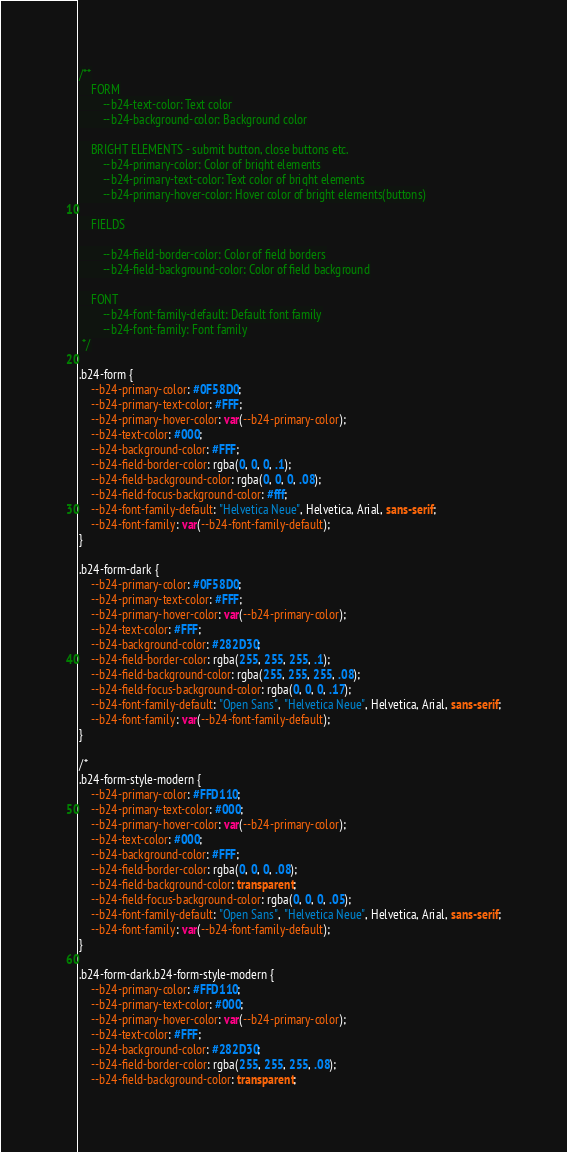<code> <loc_0><loc_0><loc_500><loc_500><_CSS_>/**
	FORM
		--b24-text-color: Text color
		--b24-background-color: Background color

	BRIGHT ELEMENTS - submit button, close buttons etc.
		--b24-primary-color: Color of bright elements
		--b24-primary-text-color: Text color of bright elements
		--b24-primary-hover-color: Hover color of bright elements(buttons)

	FIELDS

		--b24-field-border-color: Color of field borders
		--b24-field-background-color: Color of field background

	FONT
		--b24-font-family-default: Default font family
		--b24-font-family: Font family
 */

.b24-form {
	--b24-primary-color: #0F58D0;
	--b24-primary-text-color: #FFF;
	--b24-primary-hover-color: var(--b24-primary-color);
	--b24-text-color: #000;
	--b24-background-color: #FFF;
	--b24-field-border-color: rgba(0, 0, 0, .1);
	--b24-field-background-color: rgba(0, 0, 0, .08);
	--b24-field-focus-background-color: #fff;
	--b24-font-family-default: "Helvetica Neue", Helvetica, Arial, sans-serif;
	--b24-font-family: var(--b24-font-family-default);
}

.b24-form-dark {
	--b24-primary-color: #0F58D0;
	--b24-primary-text-color: #FFF;
	--b24-primary-hover-color: var(--b24-primary-color);
	--b24-text-color: #FFF;
	--b24-background-color: #282D30;
	--b24-field-border-color: rgba(255, 255, 255, .1);
	--b24-field-background-color: rgba(255, 255, 255, .08);
	--b24-field-focus-background-color: rgba(0, 0, 0, .17);
	--b24-font-family-default: "Open Sans", "Helvetica Neue", Helvetica, Arial, sans-serif;
	--b24-font-family: var(--b24-font-family-default);
}

/*
.b24-form-style-modern {
	--b24-primary-color: #FFD110;
	--b24-primary-text-color: #000;
	--b24-primary-hover-color: var(--b24-primary-color);
	--b24-text-color: #000;
	--b24-background-color: #FFF;
	--b24-field-border-color: rgba(0, 0, 0, .08);
	--b24-field-background-color: transparent;
	--b24-field-focus-background-color: rgba(0, 0, 0, .05);
	--b24-font-family-default: "Open Sans", "Helvetica Neue", Helvetica, Arial, sans-serif;
	--b24-font-family: var(--b24-font-family-default);
}

.b24-form-dark.b24-form-style-modern {
	--b24-primary-color: #FFD110;
	--b24-primary-text-color: #000;
	--b24-primary-hover-color: var(--b24-primary-color);
	--b24-text-color: #FFF;
	--b24-background-color: #282D30;
	--b24-field-border-color: rgba(255, 255, 255, .08);
	--b24-field-background-color: transparent;</code> 